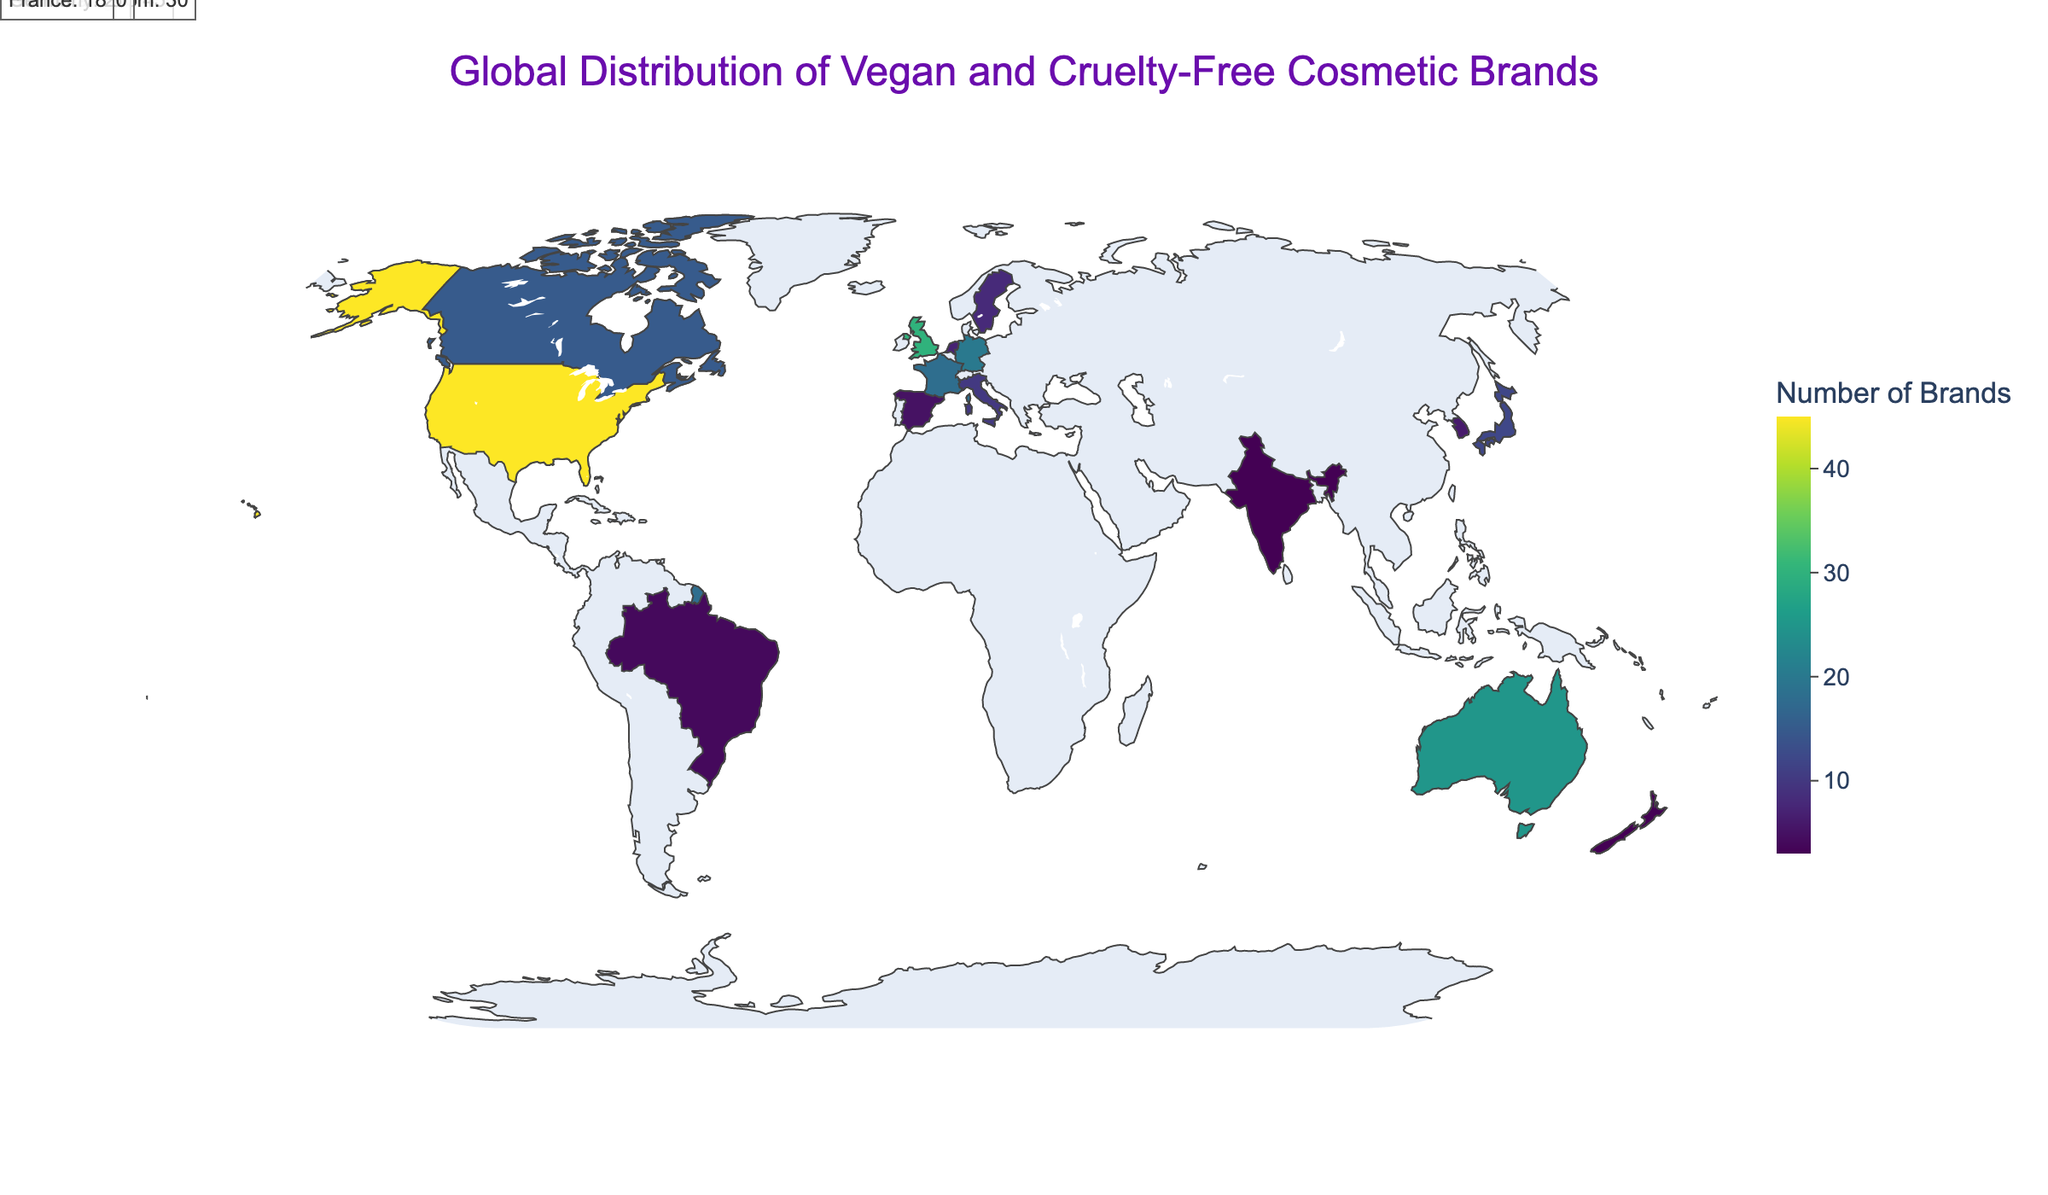what is the title of the figure? The title is displayed at the top center of the figure, indicating what the visualization represents. By reading it, one can understand the primary focus of the plot.
Answer: Global Distribution of Vegan and Cruelty-Free Cosmetic Brands Which country has the highest number of vegan and cruelty-free cosmetic brands? By examining the color intensity and hover text on each country, the one with the darkest shade and the highest total number of brands is the answer.
Answer: United States How many cruelty-free makeup brands are there in the United Kingdom? Hovering over the United Kingdom on the map shows detailed data. Look for the "Makeup" value in the hover data.
Answer: 8 What's the sum of vegan and cruelty-free skincare brands in Germany and France? Hover over Germany and France, then sum up their "Skincare" values, which are 7 for Germany and 6 for France. Therefore, the total is 7 + 6.
Answer: 13 Compare the total number of brands between Japan and Canada. Which has more? By checking the hover data or color intensity for Japan and Canada, you can see the totals provided. Japan has 12 brands and Canada has 15 brands.
Answer: Canada How many more cruelty-free haircare brands are there in the United States compared to Italy? Hovering over the United States and Italy, look at their "Haircare" values. The United States has 10, and Italy has 2. Subtract 2 from 10.
Answer: 8 Identify the country with the least vegan and cruelty-free cosmetic brands. Observe the lightest shades on the map and confirm through the hover data to find the country with the smallest total.
Answer: India or New Zealand (3 brands each) How does the number of cruelty-free fragrance brands in Brazil compare to those in Spain? By hovering over Brazil and Spain, note their "Fragrance" values. Both countries have 1 cruelty-free fragrance brand.
Answer: Equal What is the average number of vegan and cruelty-free cosmetic brands across all listed countries? Sum all the "Total_Brands" values and divide by the number of countries. The sums are 231 (45+30+25+20+18+15+12+10+8+7+6+5+4+3+3) and dividing by 15 countries, the result is 15.4.
Answer: 15.4 Which product category has the highest number of brands in Australia? Hover over Australia to see the detailed breakdown and compare the values for skincare, makeup, haircare, and fragrance. Skincare has the highest number at 8.
Answer: Skincare 